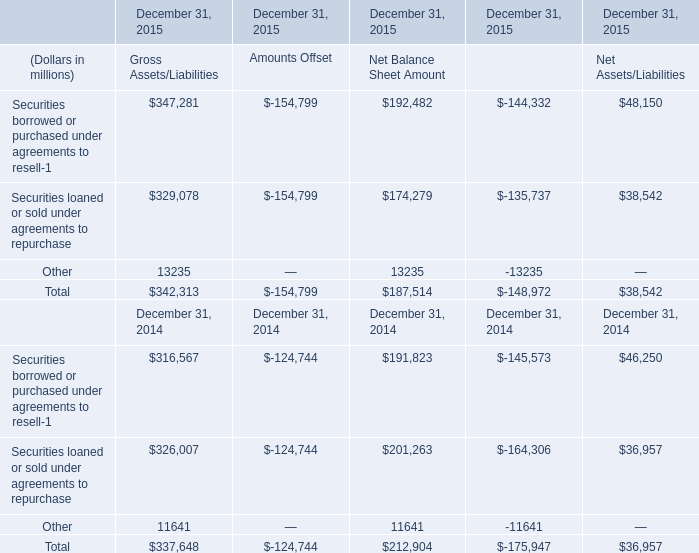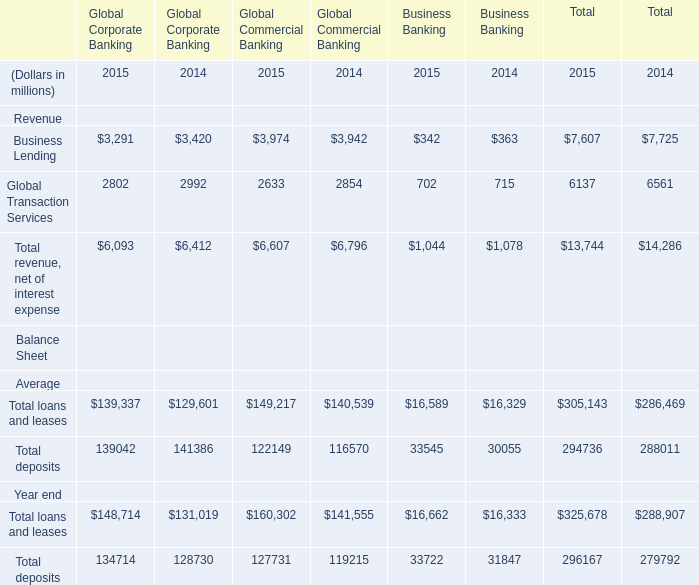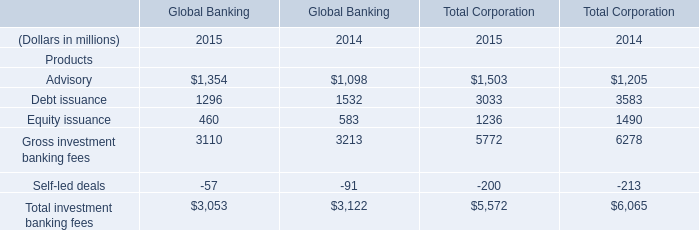What's the sum of Business Lending in 2015? (in million) 
Computations: ((3291 + 3974) + 342)
Answer: 7607.0. 